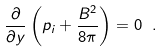<formula> <loc_0><loc_0><loc_500><loc_500>\frac { \partial } { \partial y } \left ( p _ { i } + \frac { B ^ { 2 } } { 8 \pi } \right ) = 0 \ .</formula> 